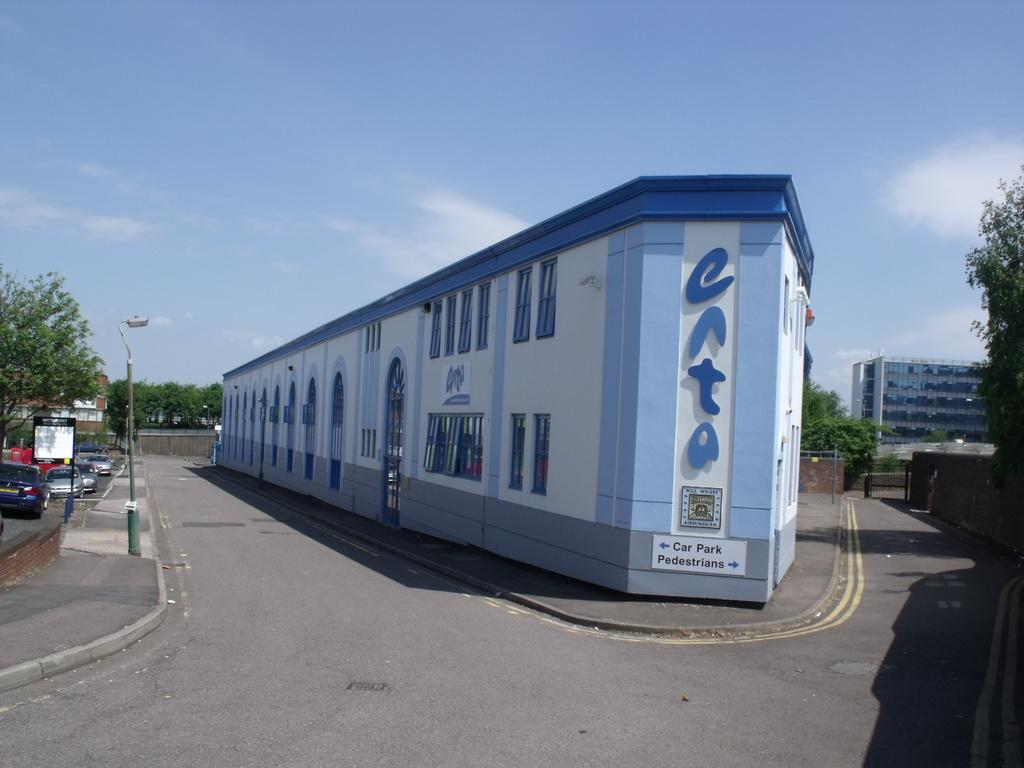<image>
Share a concise interpretation of the image provided. The sign directs car park to the left and pedestrians to the right. 